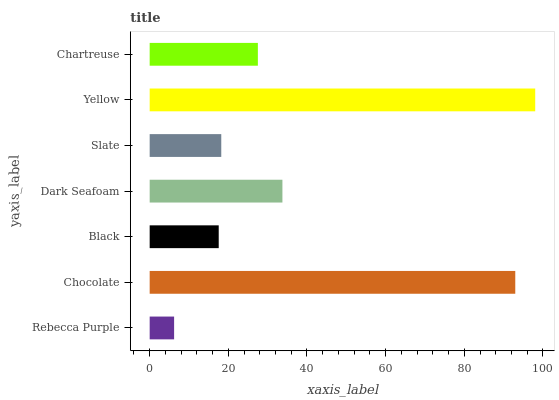Is Rebecca Purple the minimum?
Answer yes or no. Yes. Is Yellow the maximum?
Answer yes or no. Yes. Is Chocolate the minimum?
Answer yes or no. No. Is Chocolate the maximum?
Answer yes or no. No. Is Chocolate greater than Rebecca Purple?
Answer yes or no. Yes. Is Rebecca Purple less than Chocolate?
Answer yes or no. Yes. Is Rebecca Purple greater than Chocolate?
Answer yes or no. No. Is Chocolate less than Rebecca Purple?
Answer yes or no. No. Is Chartreuse the high median?
Answer yes or no. Yes. Is Chartreuse the low median?
Answer yes or no. Yes. Is Chocolate the high median?
Answer yes or no. No. Is Chocolate the low median?
Answer yes or no. No. 